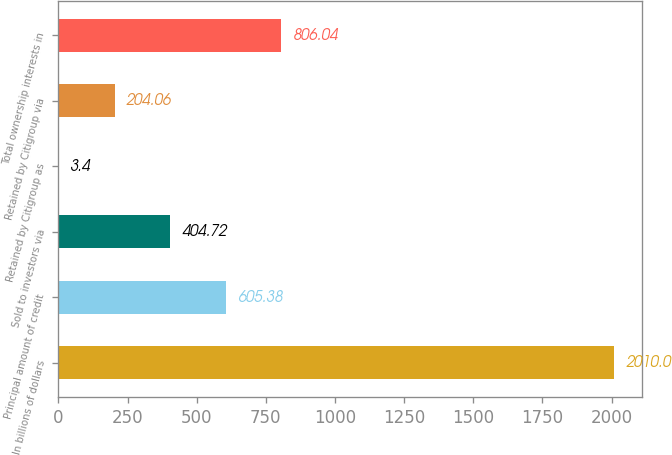<chart> <loc_0><loc_0><loc_500><loc_500><bar_chart><fcel>In billions of dollars<fcel>Principal amount of credit<fcel>Sold to investors via<fcel>Retained by Citigroup as<fcel>Retained by Citigroup via<fcel>Total ownership interests in<nl><fcel>2010<fcel>605.38<fcel>404.72<fcel>3.4<fcel>204.06<fcel>806.04<nl></chart> 